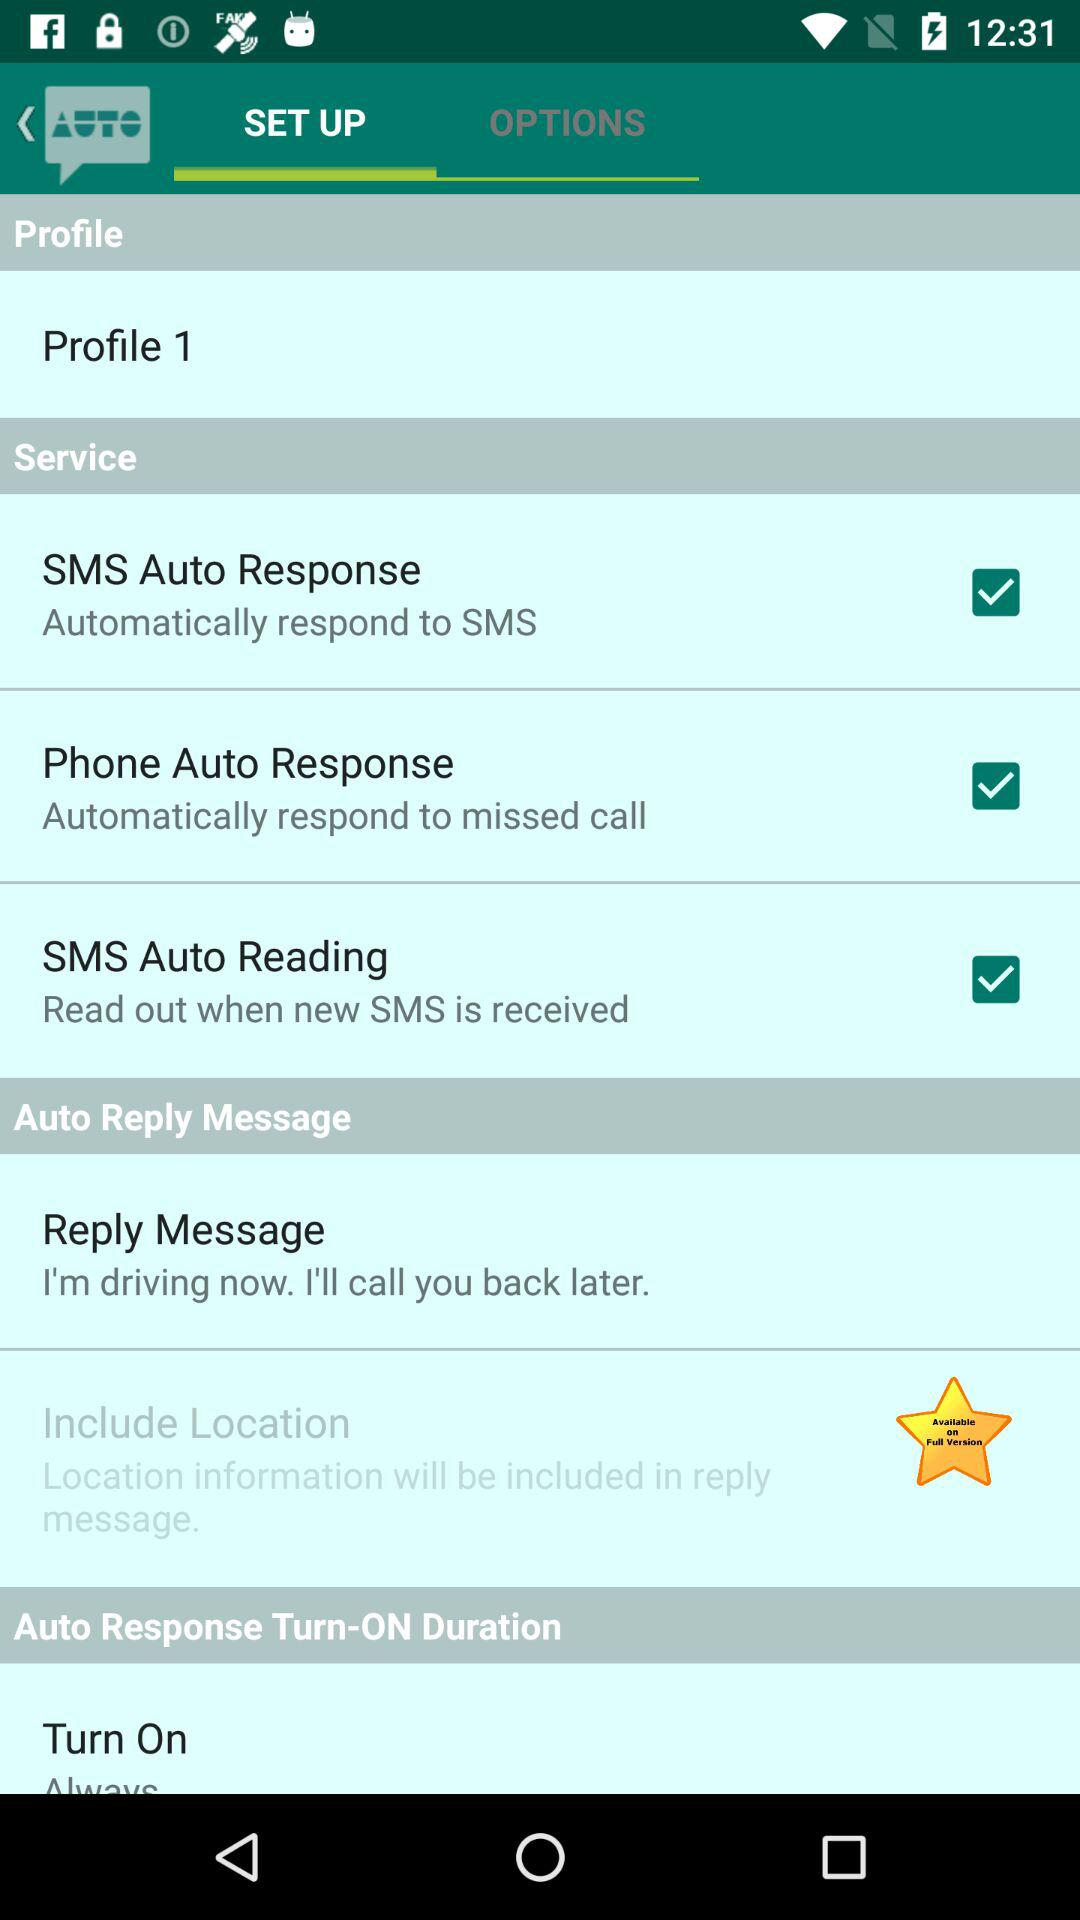What is the selected "Auto Reply Message"? The selected "Auto Reply Message" is "I'm driving now. I'll call you back later.". 